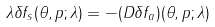Convert formula to latex. <formula><loc_0><loc_0><loc_500><loc_500>\lambda \delta f _ { s } ( \theta , p ; \lambda ) = - ( D \delta f _ { a } ) ( \theta , p ; \lambda )</formula> 